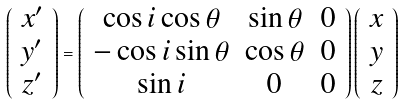<formula> <loc_0><loc_0><loc_500><loc_500>\left ( \begin{array} { c } x ^ { \prime } \\ y ^ { \prime } \\ z ^ { \prime } \end{array} \right ) = \left ( \begin{array} { c c c } \cos i \cos \theta & \sin \theta & 0 \\ - \cos i \sin \theta & \cos \theta & 0 \\ \sin i & 0 & 0 \end{array} \right ) \left ( \begin{array} { c } x \\ y \\ z \end{array} \right )</formula> 